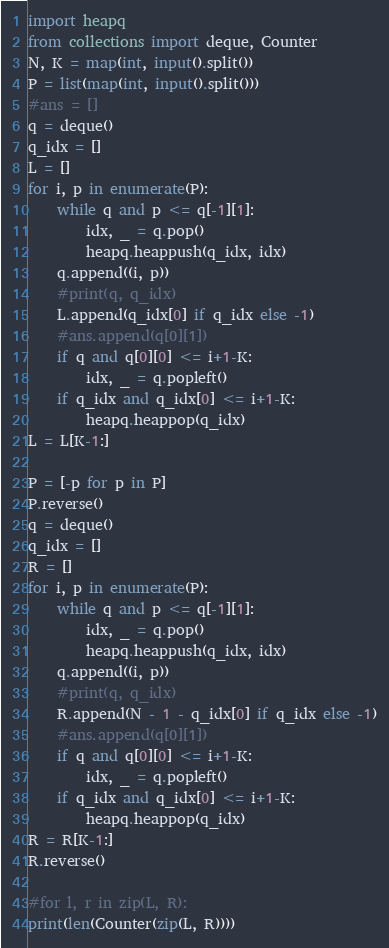<code> <loc_0><loc_0><loc_500><loc_500><_Python_>import heapq
from collections import deque, Counter
N, K = map(int, input().split())
P = list(map(int, input().split()))
#ans = []
q = deque()
q_idx = []
L = []
for i, p in enumerate(P):
    while q and p <= q[-1][1]:
        idx, _ = q.pop()
        heapq.heappush(q_idx, idx)
    q.append((i, p))
    #print(q, q_idx)
    L.append(q_idx[0] if q_idx else -1)
    #ans.append(q[0][1])
    if q and q[0][0] <= i+1-K:
        idx, _ = q.popleft()
    if q_idx and q_idx[0] <= i+1-K:
        heapq.heappop(q_idx)
L = L[K-1:]

P = [-p for p in P]
P.reverse()
q = deque()
q_idx = []
R = []
for i, p in enumerate(P):
    while q and p <= q[-1][1]:
        idx, _ = q.pop()
        heapq.heappush(q_idx, idx)
    q.append((i, p))
    #print(q, q_idx)
    R.append(N - 1 - q_idx[0] if q_idx else -1)
    #ans.append(q[0][1])
    if q and q[0][0] <= i+1-K:
        idx, _ = q.popleft()
    if q_idx and q_idx[0] <= i+1-K:
        heapq.heappop(q_idx)
R = R[K-1:]
R.reverse()

#for l, r in zip(L, R):
print(len(Counter(zip(L, R))))
</code> 